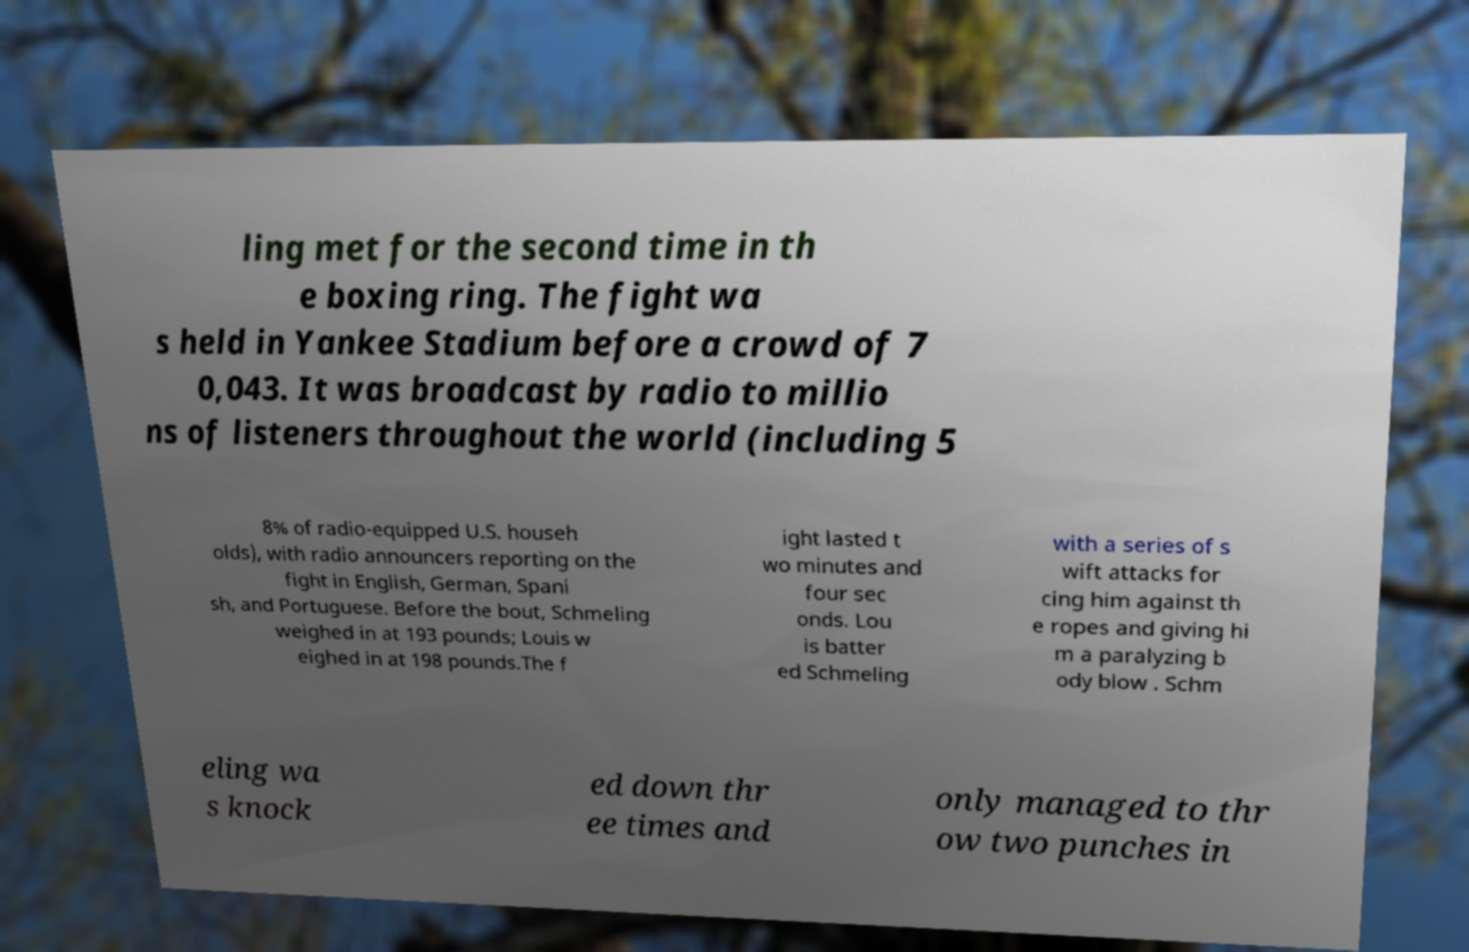Can you read and provide the text displayed in the image?This photo seems to have some interesting text. Can you extract and type it out for me? ling met for the second time in th e boxing ring. The fight wa s held in Yankee Stadium before a crowd of 7 0,043. It was broadcast by radio to millio ns of listeners throughout the world (including 5 8% of radio-equipped U.S. househ olds), with radio announcers reporting on the fight in English, German, Spani sh, and Portuguese. Before the bout, Schmeling weighed in at 193 pounds; Louis w eighed in at 198 pounds.The f ight lasted t wo minutes and four sec onds. Lou is batter ed Schmeling with a series of s wift attacks for cing him against th e ropes and giving hi m a paralyzing b ody blow . Schm eling wa s knock ed down thr ee times and only managed to thr ow two punches in 